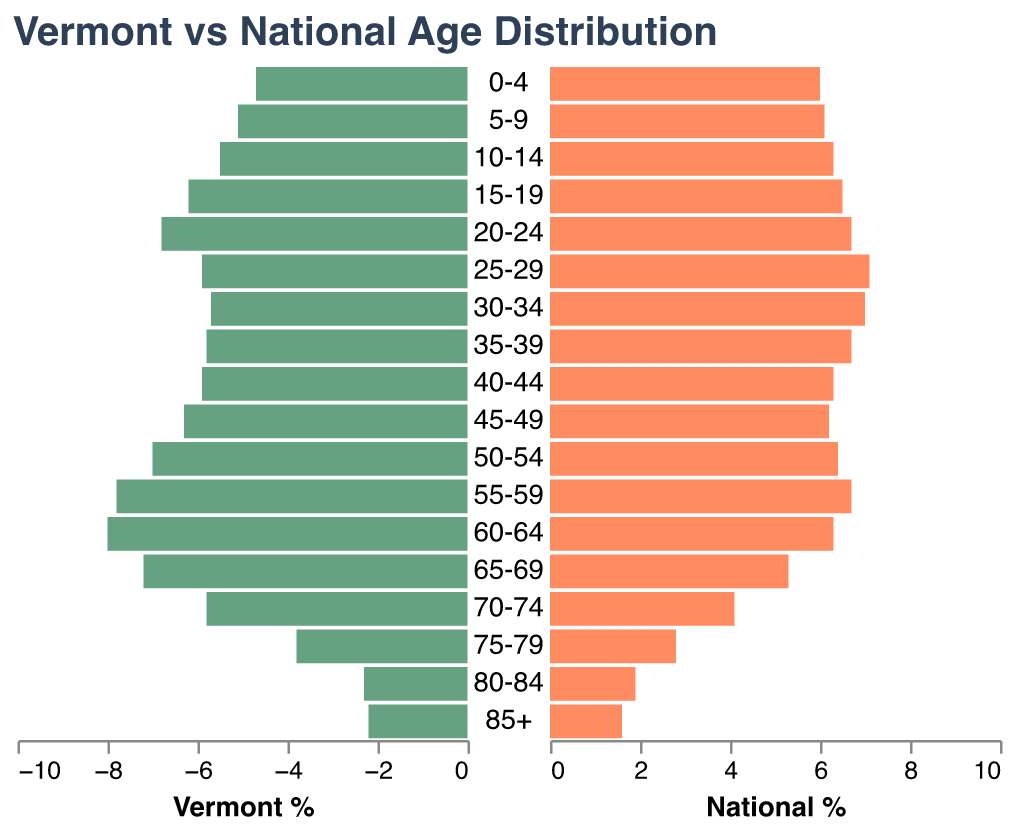What's the title of the figure? The title is positioned at the top of the chart and gives a brief overview of what the figure represents.
Answer: Vermont vs National Age Distribution What age group has the highest percentage in Vermont? Look at the bar values for Vermont. The highest bar corresponds to the age group 60-64.
Answer: 60-64 How do the percentages of the age group 25-29 compare between Vermont and the national averages? Compare the length of the bars for the age group 25-29 on both sides of the pyramid. Vermont is 5.9%, and the national average is 7.1%.
Answer: Vermont: 5.9%, National: 7.1% What's the combined percentage of people aged 70-74 and 75-79 in Vermont? Sum the values for the age groups 70-74 (5.8%) and 75-79 (3.8%).
Answer: 9.6% In which age group does Vermont have a larger percentage than the national average? Compare the bar lengths for each age group. Several age groups meet this criterion: 20-24, 45-49, 50-54, 55-59, 60-64, 65-69, 70-74, 75-79, 80-84, and 85+.
Answer: 20-24, 45-49, 50-54, 55-59, 60-64, 65-69, 70-74, 75-79, 80-84, 85+ Which age group has the smallest population percentage nationally? Look for the shortest bar on the national side of the pyramid. The age group 85+ has the smallest percentage nationally.
Answer: 85+ How many age groups have a higher percentage in Vermont than the national average? Count the age groups where the Vermont bar is longer. There are ten such age groups.
Answer: 10 